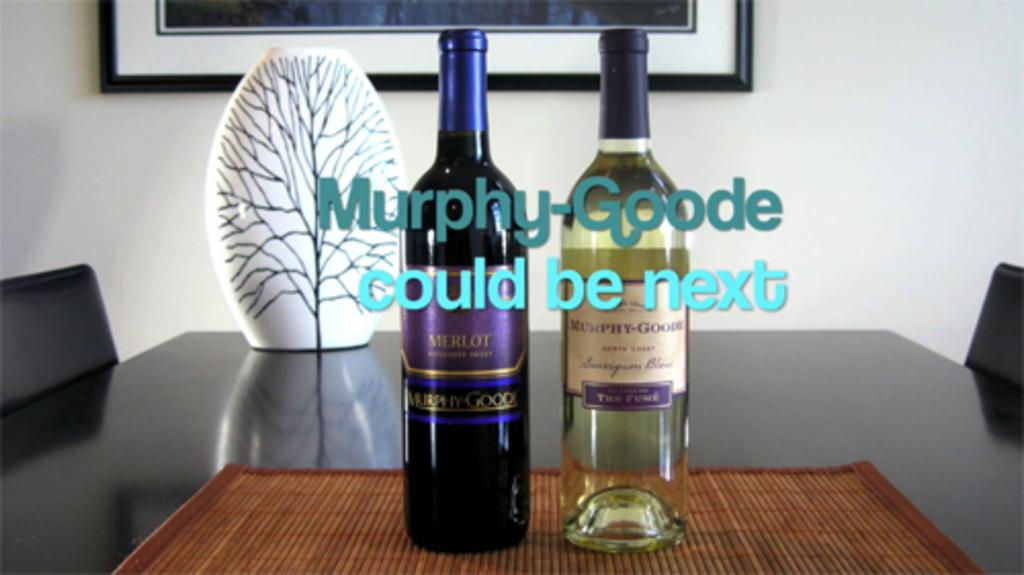Provide a one-sentence caption for the provided image. Two bottles of Murphy-Goode wine bottles are displayed on a conference table. 